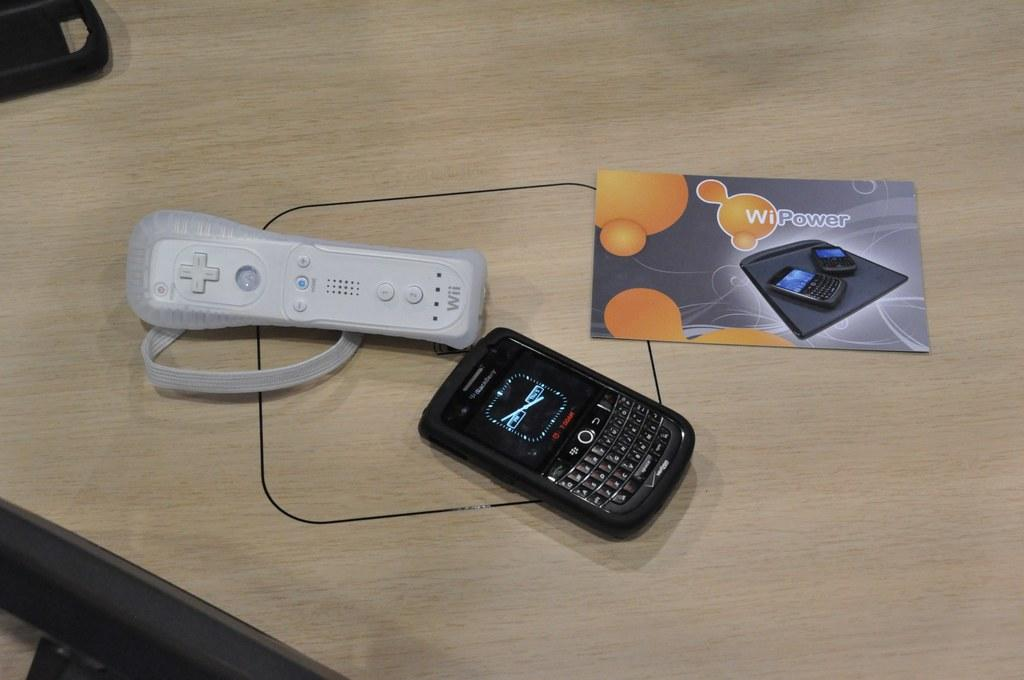<image>
Provide a brief description of the given image. a wii remote, black blackberry phone and paper on the top of table 